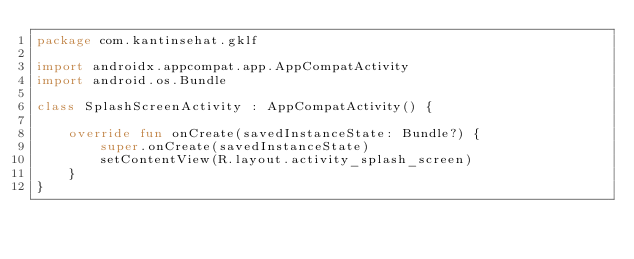<code> <loc_0><loc_0><loc_500><loc_500><_Kotlin_>package com.kantinsehat.gklf

import androidx.appcompat.app.AppCompatActivity
import android.os.Bundle

class SplashScreenActivity : AppCompatActivity() {

    override fun onCreate(savedInstanceState: Bundle?) {
        super.onCreate(savedInstanceState)
        setContentView(R.layout.activity_splash_screen)
    }
}
</code> 